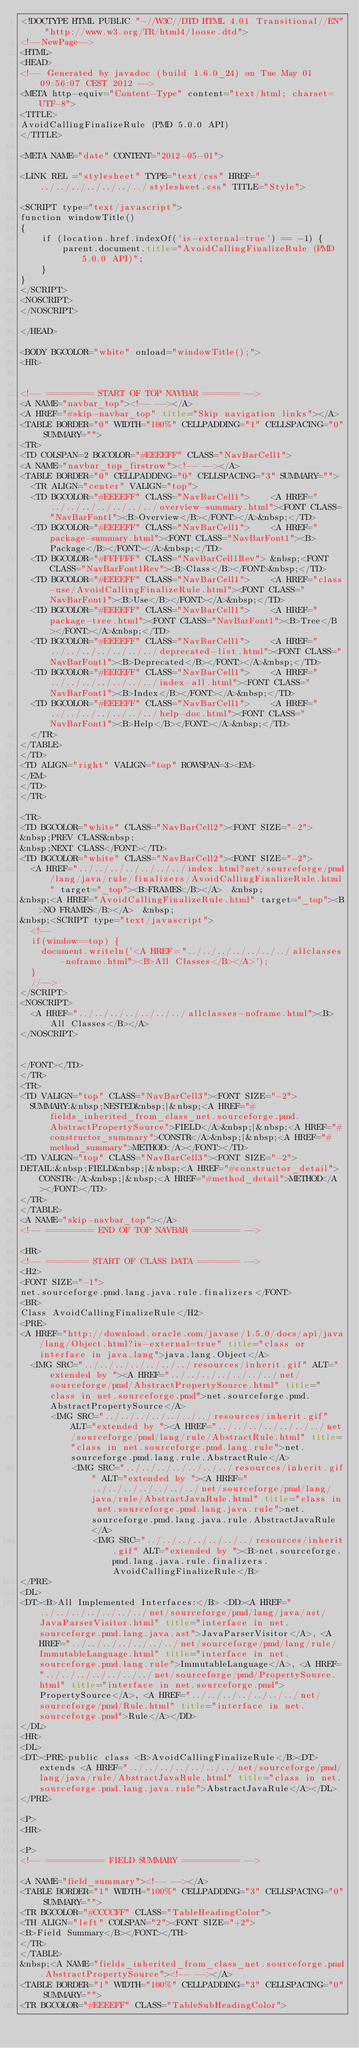<code> <loc_0><loc_0><loc_500><loc_500><_HTML_><!DOCTYPE HTML PUBLIC "-//W3C//DTD HTML 4.01 Transitional//EN" "http://www.w3.org/TR/html4/loose.dtd">
<!--NewPage-->
<HTML>
<HEAD>
<!-- Generated by javadoc (build 1.6.0_24) on Tue May 01 09:56:07 CEST 2012 -->
<META http-equiv="Content-Type" content="text/html; charset=UTF-8">
<TITLE>
AvoidCallingFinalizeRule (PMD 5.0.0 API)
</TITLE>

<META NAME="date" CONTENT="2012-05-01">

<LINK REL ="stylesheet" TYPE="text/css" HREF="../../../../../../../stylesheet.css" TITLE="Style">

<SCRIPT type="text/javascript">
function windowTitle()
{
    if (location.href.indexOf('is-external=true') == -1) {
        parent.document.title="AvoidCallingFinalizeRule (PMD 5.0.0 API)";
    }
}
</SCRIPT>
<NOSCRIPT>
</NOSCRIPT>

</HEAD>

<BODY BGCOLOR="white" onload="windowTitle();">
<HR>


<!-- ========= START OF TOP NAVBAR ======= -->
<A NAME="navbar_top"><!-- --></A>
<A HREF="#skip-navbar_top" title="Skip navigation links"></A>
<TABLE BORDER="0" WIDTH="100%" CELLPADDING="1" CELLSPACING="0" SUMMARY="">
<TR>
<TD COLSPAN=2 BGCOLOR="#EEEEFF" CLASS="NavBarCell1">
<A NAME="navbar_top_firstrow"><!-- --></A>
<TABLE BORDER="0" CELLPADDING="0" CELLSPACING="3" SUMMARY="">
  <TR ALIGN="center" VALIGN="top">
  <TD BGCOLOR="#EEEEFF" CLASS="NavBarCell1">    <A HREF="../../../../../../../overview-summary.html"><FONT CLASS="NavBarFont1"><B>Overview</B></FONT></A>&nbsp;</TD>
  <TD BGCOLOR="#EEEEFF" CLASS="NavBarCell1">    <A HREF="package-summary.html"><FONT CLASS="NavBarFont1"><B>Package</B></FONT></A>&nbsp;</TD>
  <TD BGCOLOR="#FFFFFF" CLASS="NavBarCell1Rev"> &nbsp;<FONT CLASS="NavBarFont1Rev"><B>Class</B></FONT>&nbsp;</TD>
  <TD BGCOLOR="#EEEEFF" CLASS="NavBarCell1">    <A HREF="class-use/AvoidCallingFinalizeRule.html"><FONT CLASS="NavBarFont1"><B>Use</B></FONT></A>&nbsp;</TD>
  <TD BGCOLOR="#EEEEFF" CLASS="NavBarCell1">    <A HREF="package-tree.html"><FONT CLASS="NavBarFont1"><B>Tree</B></FONT></A>&nbsp;</TD>
  <TD BGCOLOR="#EEEEFF" CLASS="NavBarCell1">    <A HREF="../../../../../../../deprecated-list.html"><FONT CLASS="NavBarFont1"><B>Deprecated</B></FONT></A>&nbsp;</TD>
  <TD BGCOLOR="#EEEEFF" CLASS="NavBarCell1">    <A HREF="../../../../../../../index-all.html"><FONT CLASS="NavBarFont1"><B>Index</B></FONT></A>&nbsp;</TD>
  <TD BGCOLOR="#EEEEFF" CLASS="NavBarCell1">    <A HREF="../../../../../../../help-doc.html"><FONT CLASS="NavBarFont1"><B>Help</B></FONT></A>&nbsp;</TD>
  </TR>
</TABLE>
</TD>
<TD ALIGN="right" VALIGN="top" ROWSPAN=3><EM>
</EM>
</TD>
</TR>

<TR>
<TD BGCOLOR="white" CLASS="NavBarCell2"><FONT SIZE="-2">
&nbsp;PREV CLASS&nbsp;
&nbsp;NEXT CLASS</FONT></TD>
<TD BGCOLOR="white" CLASS="NavBarCell2"><FONT SIZE="-2">
  <A HREF="../../../../../../../index.html?net/sourceforge/pmd/lang/java/rule/finalizers/AvoidCallingFinalizeRule.html" target="_top"><B>FRAMES</B></A>  &nbsp;
&nbsp;<A HREF="AvoidCallingFinalizeRule.html" target="_top"><B>NO FRAMES</B></A>  &nbsp;
&nbsp;<SCRIPT type="text/javascript">
  <!--
  if(window==top) {
    document.writeln('<A HREF="../../../../../../../allclasses-noframe.html"><B>All Classes</B></A>');
  }
  //-->
</SCRIPT>
<NOSCRIPT>
  <A HREF="../../../../../../../allclasses-noframe.html"><B>All Classes</B></A>
</NOSCRIPT>


</FONT></TD>
</TR>
<TR>
<TD VALIGN="top" CLASS="NavBarCell3"><FONT SIZE="-2">
  SUMMARY:&nbsp;NESTED&nbsp;|&nbsp;<A HREF="#fields_inherited_from_class_net.sourceforge.pmd.AbstractPropertySource">FIELD</A>&nbsp;|&nbsp;<A HREF="#constructor_summary">CONSTR</A>&nbsp;|&nbsp;<A HREF="#method_summary">METHOD</A></FONT></TD>
<TD VALIGN="top" CLASS="NavBarCell3"><FONT SIZE="-2">
DETAIL:&nbsp;FIELD&nbsp;|&nbsp;<A HREF="#constructor_detail">CONSTR</A>&nbsp;|&nbsp;<A HREF="#method_detail">METHOD</A></FONT></TD>
</TR>
</TABLE>
<A NAME="skip-navbar_top"></A>
<!-- ========= END OF TOP NAVBAR ========= -->

<HR>
<!-- ======== START OF CLASS DATA ======== -->
<H2>
<FONT SIZE="-1">
net.sourceforge.pmd.lang.java.rule.finalizers</FONT>
<BR>
Class AvoidCallingFinalizeRule</H2>
<PRE>
<A HREF="http://download.oracle.com/javase/1.5.0/docs/api/java/lang/Object.html?is-external=true" title="class or interface in java.lang">java.lang.Object</A>
  <IMG SRC="../../../../../../../resources/inherit.gif" ALT="extended by "><A HREF="../../../../../../../net/sourceforge/pmd/AbstractPropertySource.html" title="class in net.sourceforge.pmd">net.sourceforge.pmd.AbstractPropertySource</A>
      <IMG SRC="../../../../../../../resources/inherit.gif" ALT="extended by "><A HREF="../../../../../../../net/sourceforge/pmd/lang/rule/AbstractRule.html" title="class in net.sourceforge.pmd.lang.rule">net.sourceforge.pmd.lang.rule.AbstractRule</A>
          <IMG SRC="../../../../../../../resources/inherit.gif" ALT="extended by "><A HREF="../../../../../../../net/sourceforge/pmd/lang/java/rule/AbstractJavaRule.html" title="class in net.sourceforge.pmd.lang.java.rule">net.sourceforge.pmd.lang.java.rule.AbstractJavaRule</A>
              <IMG SRC="../../../../../../../resources/inherit.gif" ALT="extended by "><B>net.sourceforge.pmd.lang.java.rule.finalizers.AvoidCallingFinalizeRule</B>
</PRE>
<DL>
<DT><B>All Implemented Interfaces:</B> <DD><A HREF="../../../../../../../net/sourceforge/pmd/lang/java/ast/JavaParserVisitor.html" title="interface in net.sourceforge.pmd.lang.java.ast">JavaParserVisitor</A>, <A HREF="../../../../../../../net/sourceforge/pmd/lang/rule/ImmutableLanguage.html" title="interface in net.sourceforge.pmd.lang.rule">ImmutableLanguage</A>, <A HREF="../../../../../../../net/sourceforge/pmd/PropertySource.html" title="interface in net.sourceforge.pmd">PropertySource</A>, <A HREF="../../../../../../../net/sourceforge/pmd/Rule.html" title="interface in net.sourceforge.pmd">Rule</A></DD>
</DL>
<HR>
<DL>
<DT><PRE>public class <B>AvoidCallingFinalizeRule</B><DT>extends <A HREF="../../../../../../../net/sourceforge/pmd/lang/java/rule/AbstractJavaRule.html" title="class in net.sourceforge.pmd.lang.java.rule">AbstractJavaRule</A></DL>
</PRE>

<P>
<HR>

<P>
<!-- =========== FIELD SUMMARY =========== -->

<A NAME="field_summary"><!-- --></A>
<TABLE BORDER="1" WIDTH="100%" CELLPADDING="3" CELLSPACING="0" SUMMARY="">
<TR BGCOLOR="#CCCCFF" CLASS="TableHeadingColor">
<TH ALIGN="left" COLSPAN="2"><FONT SIZE="+2">
<B>Field Summary</B></FONT></TH>
</TR>
</TABLE>
&nbsp;<A NAME="fields_inherited_from_class_net.sourceforge.pmd.AbstractPropertySource"><!-- --></A>
<TABLE BORDER="1" WIDTH="100%" CELLPADDING="3" CELLSPACING="0" SUMMARY="">
<TR BGCOLOR="#EEEEFF" CLASS="TableSubHeadingColor"></code> 